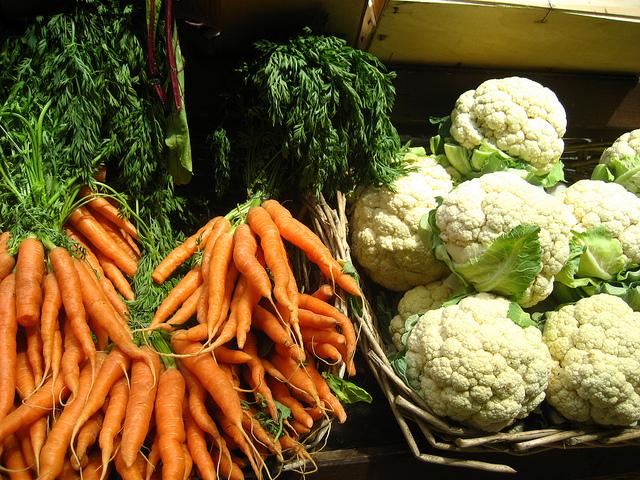What are the vegetables next to the carrots?
Be succinct. Cauliflower. Where are the carrots?
Answer briefly. Left. Was this picture taken outside?
Write a very short answer. Yes. 